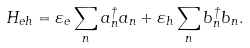Convert formula to latex. <formula><loc_0><loc_0><loc_500><loc_500>H _ { e h } = \varepsilon _ { e } \sum _ { n } a _ { n } ^ { \dagger } a _ { n } + \varepsilon _ { h } \sum _ { n } b _ { n } ^ { \dagger } b _ { n } .</formula> 